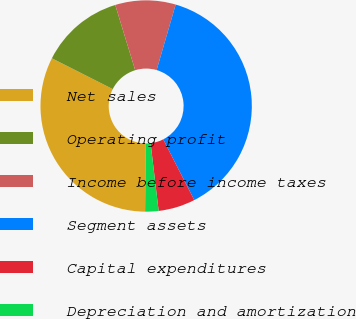<chart> <loc_0><loc_0><loc_500><loc_500><pie_chart><fcel>Net sales<fcel>Operating profit<fcel>Income before income taxes<fcel>Segment assets<fcel>Capital expenditures<fcel>Depreciation and amortization<nl><fcel>32.3%<fcel>12.82%<fcel>9.23%<fcel>37.97%<fcel>5.64%<fcel>2.05%<nl></chart> 